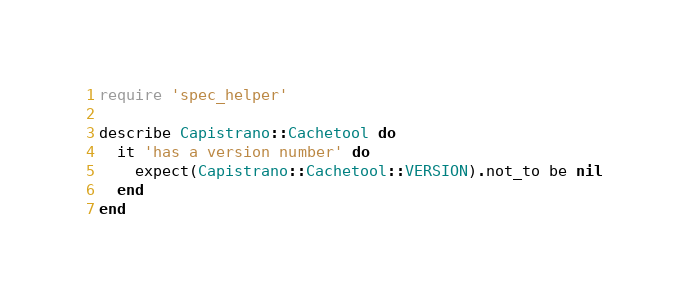Convert code to text. <code><loc_0><loc_0><loc_500><loc_500><_Ruby_>require 'spec_helper'

describe Capistrano::Cachetool do
  it 'has a version number' do
    expect(Capistrano::Cachetool::VERSION).not_to be nil
  end
end
</code> 